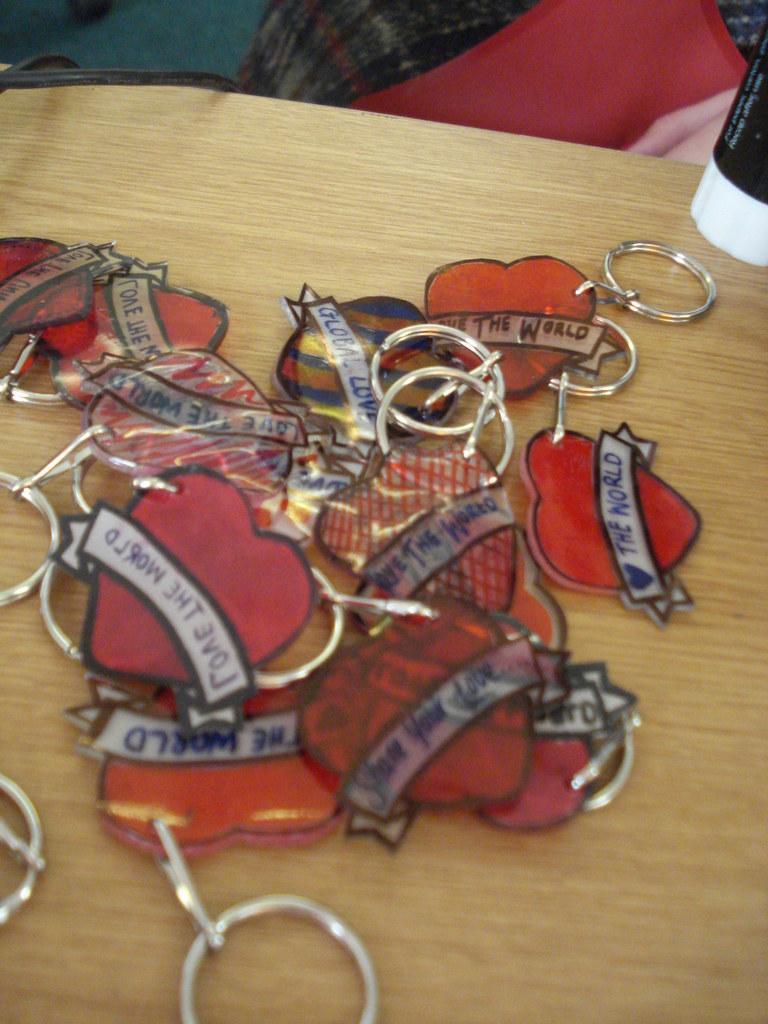In one or two sentences, can you explain what this image depicts? In the image on the wooden surface there are key chains which are in love shape and also there is text on it. In the top right corner of the image there is an object. 